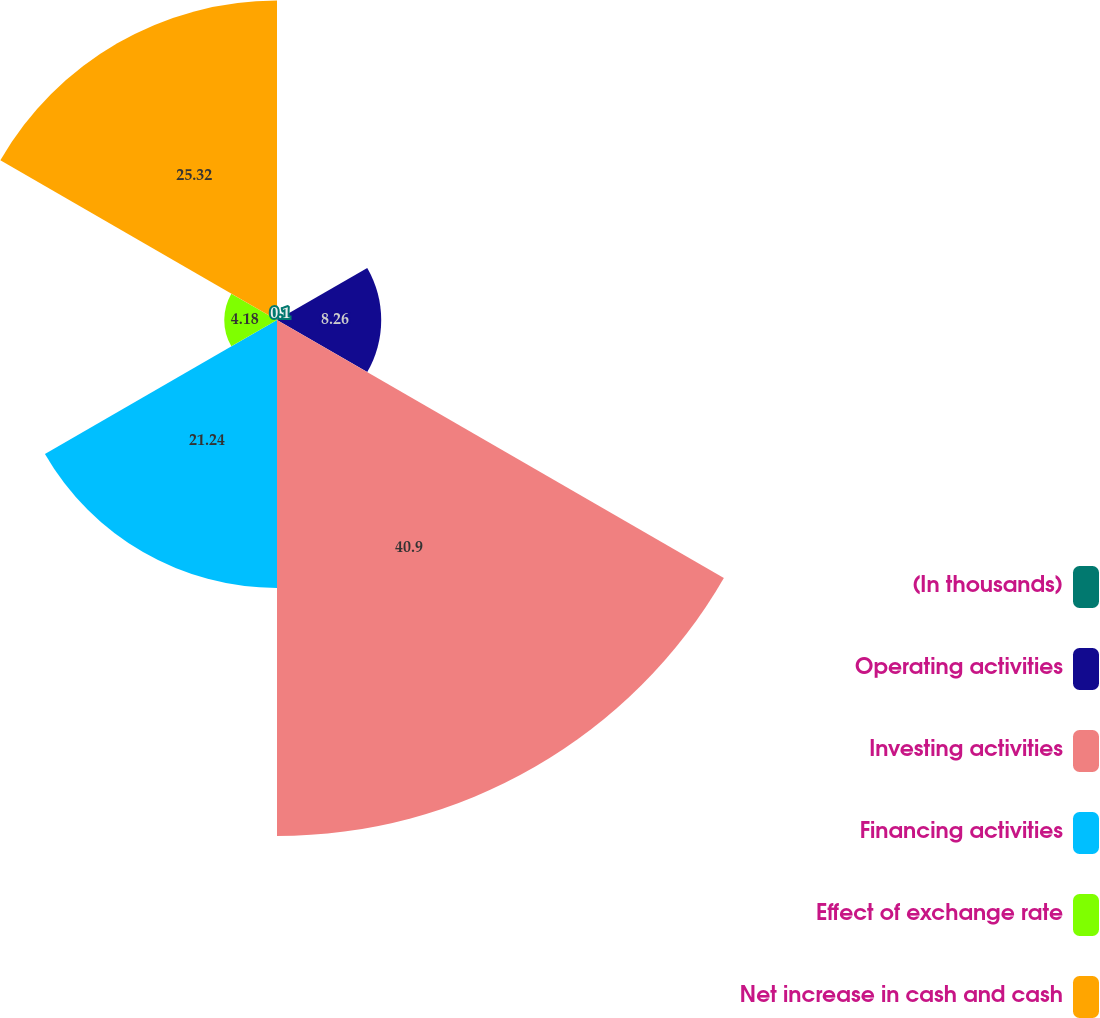Convert chart to OTSL. <chart><loc_0><loc_0><loc_500><loc_500><pie_chart><fcel>(In thousands)<fcel>Operating activities<fcel>Investing activities<fcel>Financing activities<fcel>Effect of exchange rate<fcel>Net increase in cash and cash<nl><fcel>0.1%<fcel>8.26%<fcel>40.9%<fcel>21.24%<fcel>4.18%<fcel>25.32%<nl></chart> 